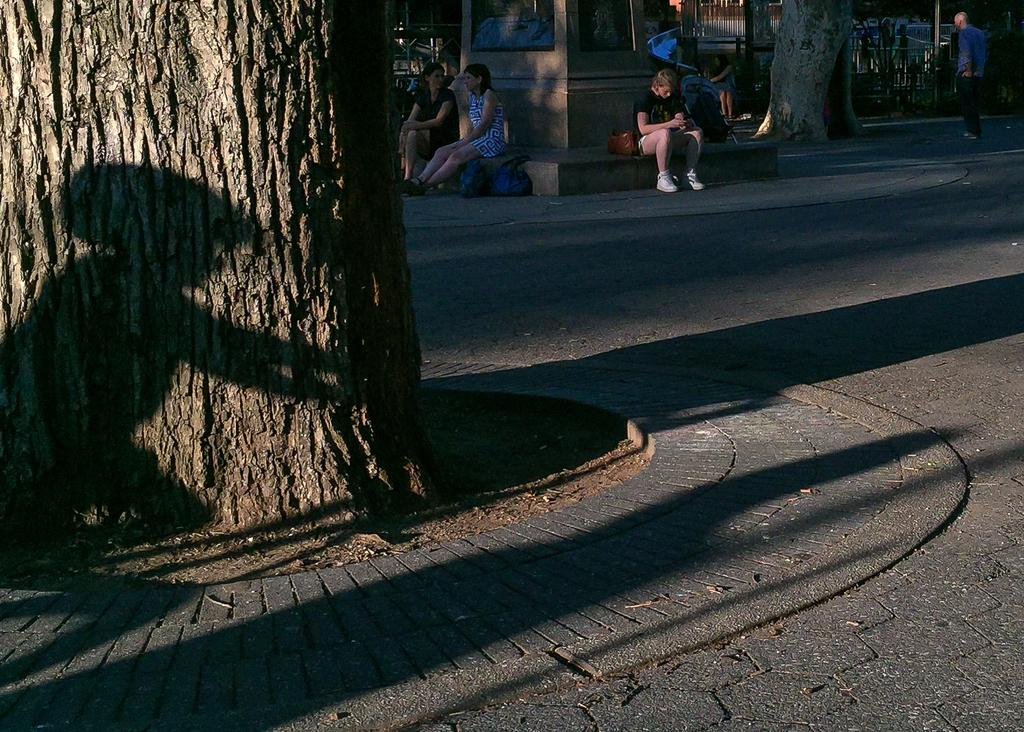What type of natural elements can be seen in the image? There are tree trunks in the image. Where is the man located in the image? The man is standing on the road in the image. What are the people in the image doing? The people are sitting in the image. What objects might be used for carrying items in the image? Bags are visible in the image. How many chairs are present in the image? There are no chairs visible in the image. 